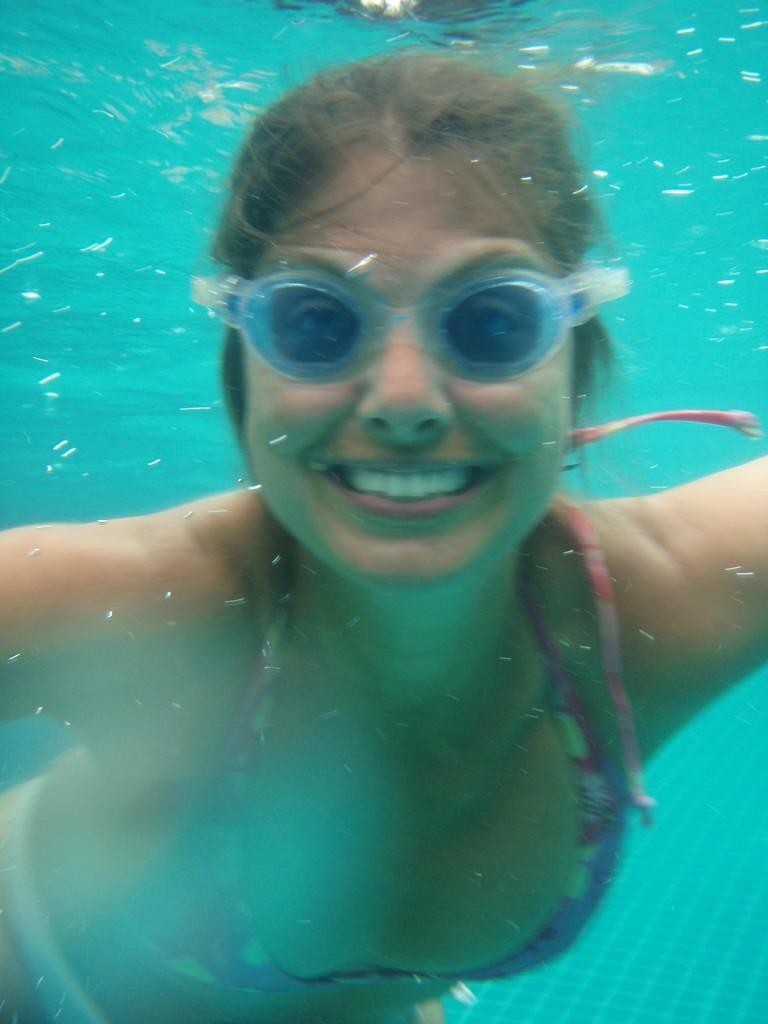Can you describe this image briefly? In this picture I can see a woman in the water and I see that she is smiling. I can also see that she is wearing swimming goggles. 